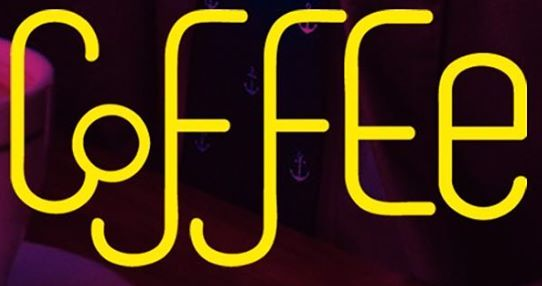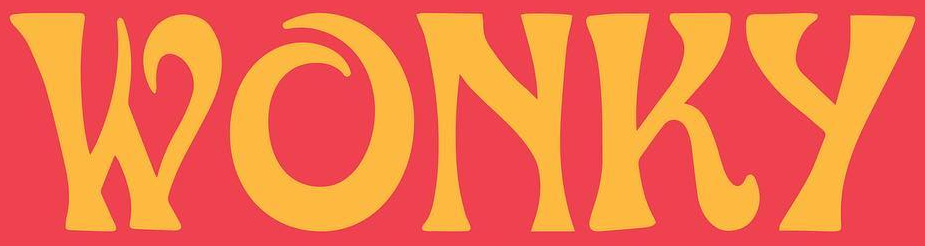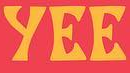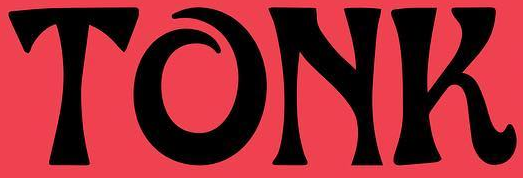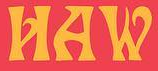Read the text content from these images in order, separated by a semicolon. CoffEe; WONKy; yEE; TONK; HAW 